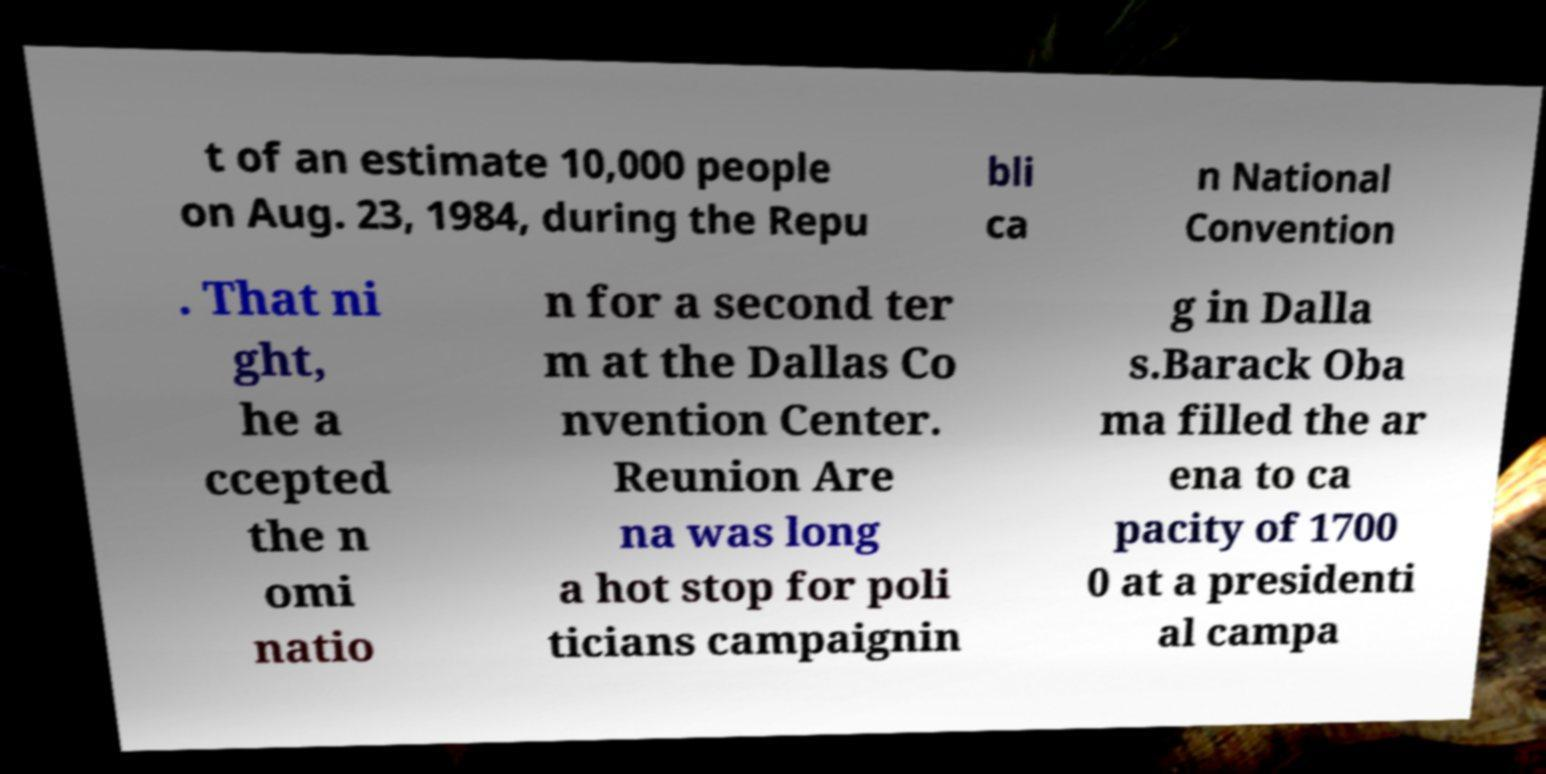Can you accurately transcribe the text from the provided image for me? t of an estimate 10,000 people on Aug. 23, 1984, during the Repu bli ca n National Convention . That ni ght, he a ccepted the n omi natio n for a second ter m at the Dallas Co nvention Center. Reunion Are na was long a hot stop for poli ticians campaignin g in Dalla s.Barack Oba ma filled the ar ena to ca pacity of 1700 0 at a presidenti al campa 